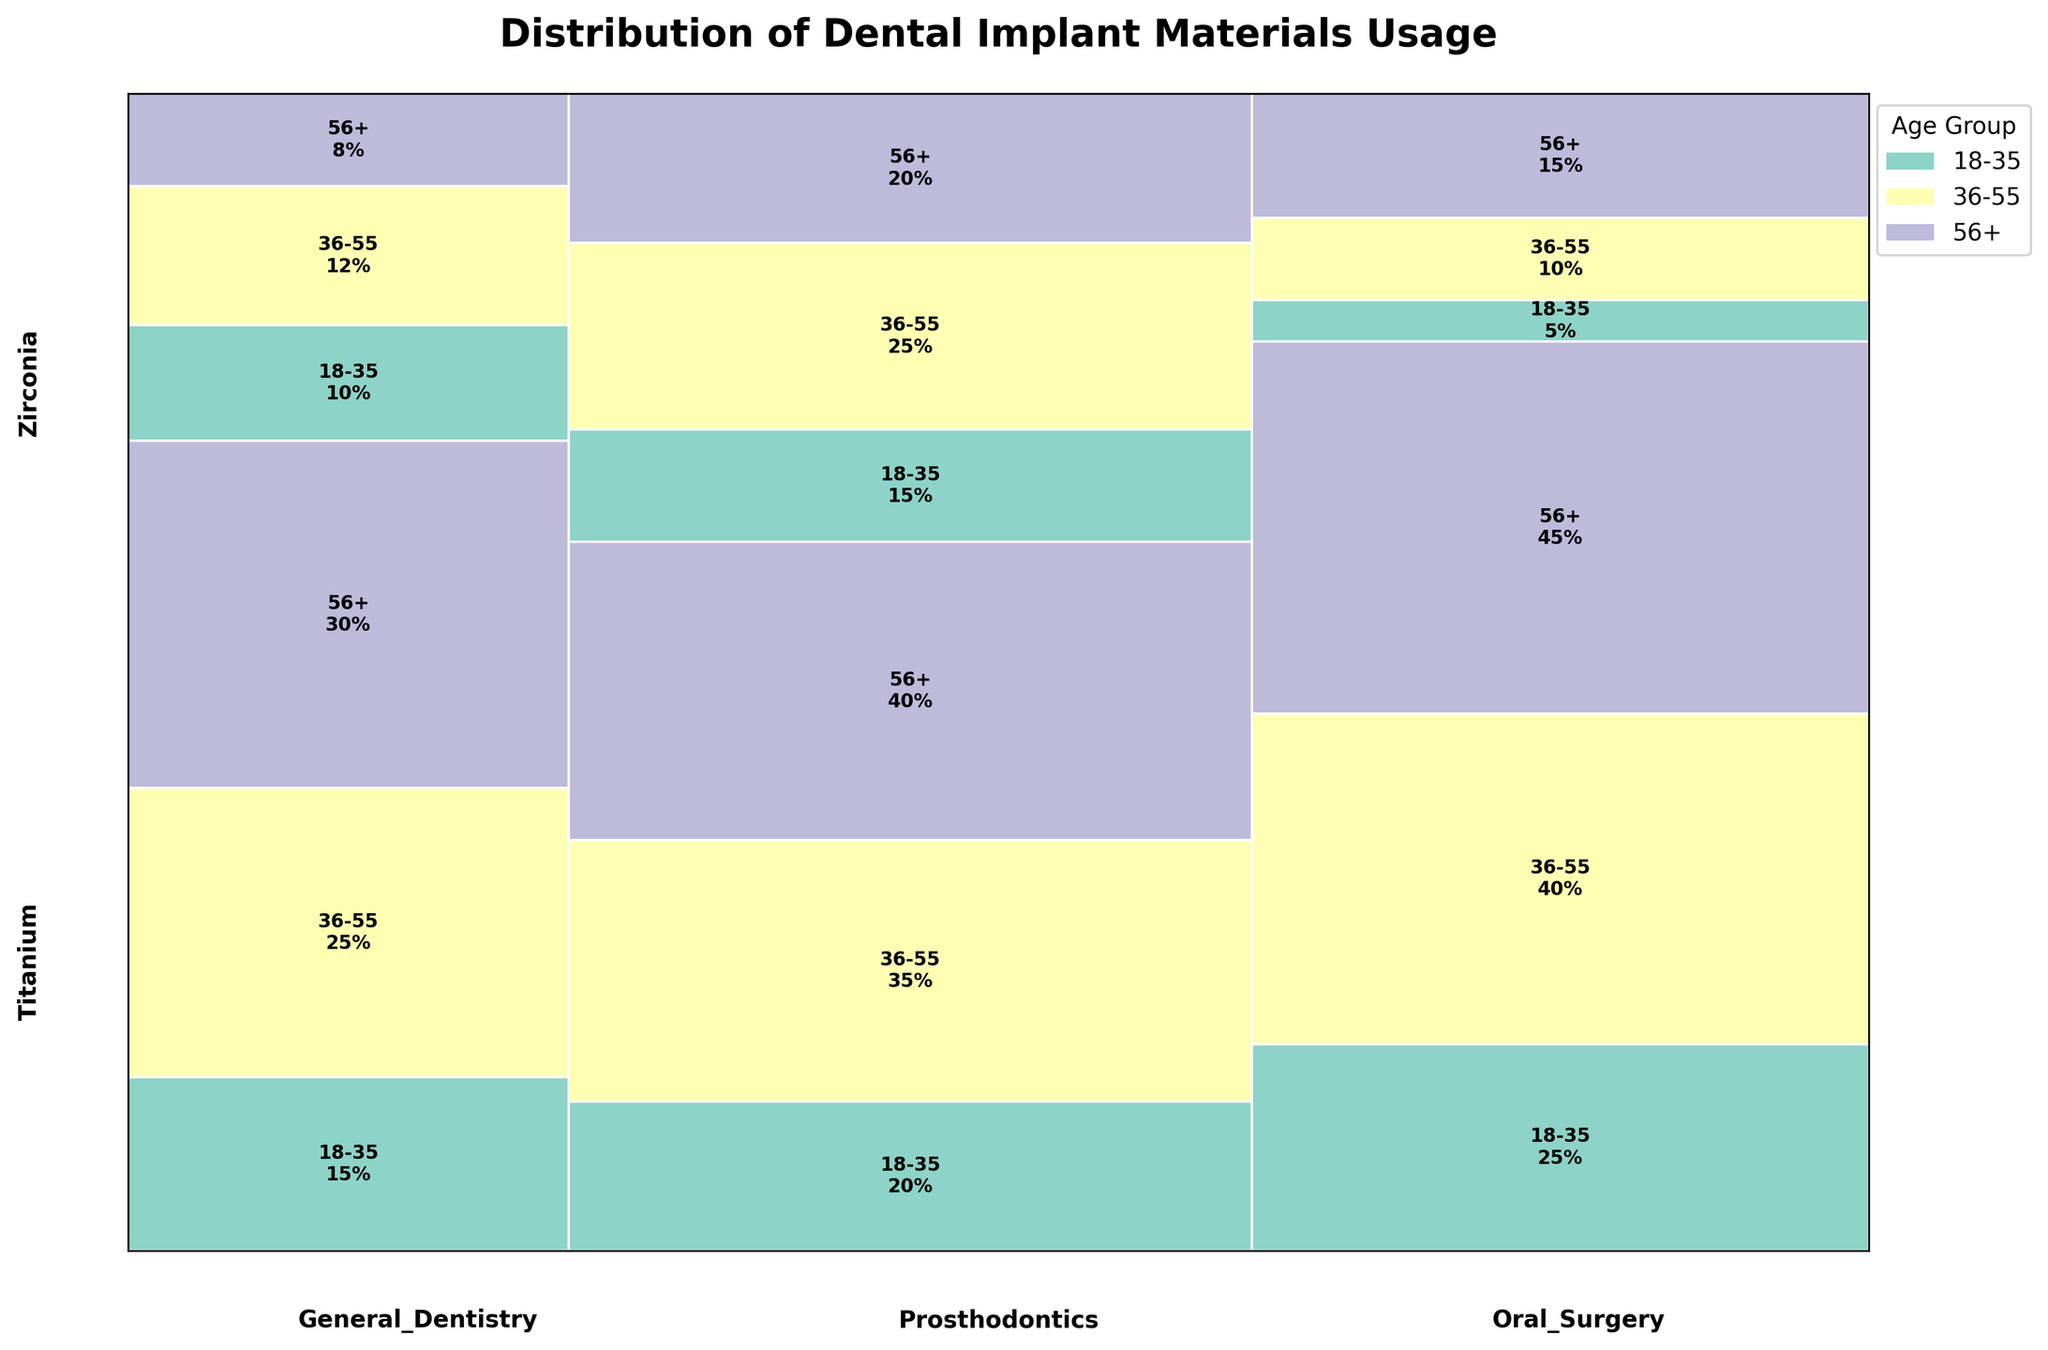What is the title of the mosaic plot? The title of the mosaic plot is typically displayed at the top of the figure. In this case, by referring to the data and the provided code, the title is "Distribution of Dental Implant Materials Usage".
Answer: Distribution of Dental Implant Materials Usage How is the proportion of Titanium usage in the 56+ age group compared between General Dentistry and Oral Surgery? To determine the proportion of Titanium usage in the 56+ age group for both specialties, you need to look at the size of the respective segments in the mosaic plot for General Dentistry and Oral Surgery. In General Dentistry, the proportion is 30%, while in Oral Surgery, it is 45%.
Answer: Oral Surgery is higher Which dental specialty has the highest usage percentage of Zirconia implants in the 36-55 age group? To find this, look at the segments representing Zirconia usage for the 36-55 age group across all specialties. Prosthodontics has a 25% usage, which is higher than General Dentistry's 12% and Oral Surgery's 10%.
Answer: Prosthodontics What is the total usage percentage for Titanium implants in Prosthodontics across all age groups? To find the total, sum up the usage percentages of Titanium implants in Prosthodontics across all age groups: 20% (18-35) + 35% (36-55) + 40% (56+), which equals 95%.
Answer: 95% How does the usage of Zirconia implants in the 18-35 age group compare between General Dentistry and Prosthodontics? Look at the segments for Zirconia usage in the 18-35 age group in both specialties. General Dentistry shows a 10% usage, while Prosthodontics shows a 15% usage. Hence, Prosthodontics has a higher percentage.
Answer: Prosthodontics is higher Which age group has the highest percentage for Titanium usage across all specialties? Examine each age group across all specialties for Titanium usage. The percentages are: 18-35 has 15% + 20% + 25% = 60%, 36-55 has 25% + 35% + 40% = 100%, 56+ has 30% + 40% + 45% = 115%. The age group 56+ has the highest percentage.
Answer: 56+ What is the combined usage percentage of Zirconia in the 56+ age group across all specialties? Sum up the percentages of Zirconia usage in the 56+ age group for all specialties: 8% (General Dentistry) + 20% (Prosthodontics) + 15% (Oral Surgery), which equals 43%.
Answer: 43% Compare the total usage percentage of Titanium versus Zirconia in General Dentistry. For Titanium in General Dentistry: 15% (18-35) + 25% (36-55) + 30% (56+) equals 70%. For Zirconia: 10% (18-35) + 12% (36-55) + 8% (56+) equals 30%. So, Titanium has a higher total usage percentage.
Answer: Titanium is higher 